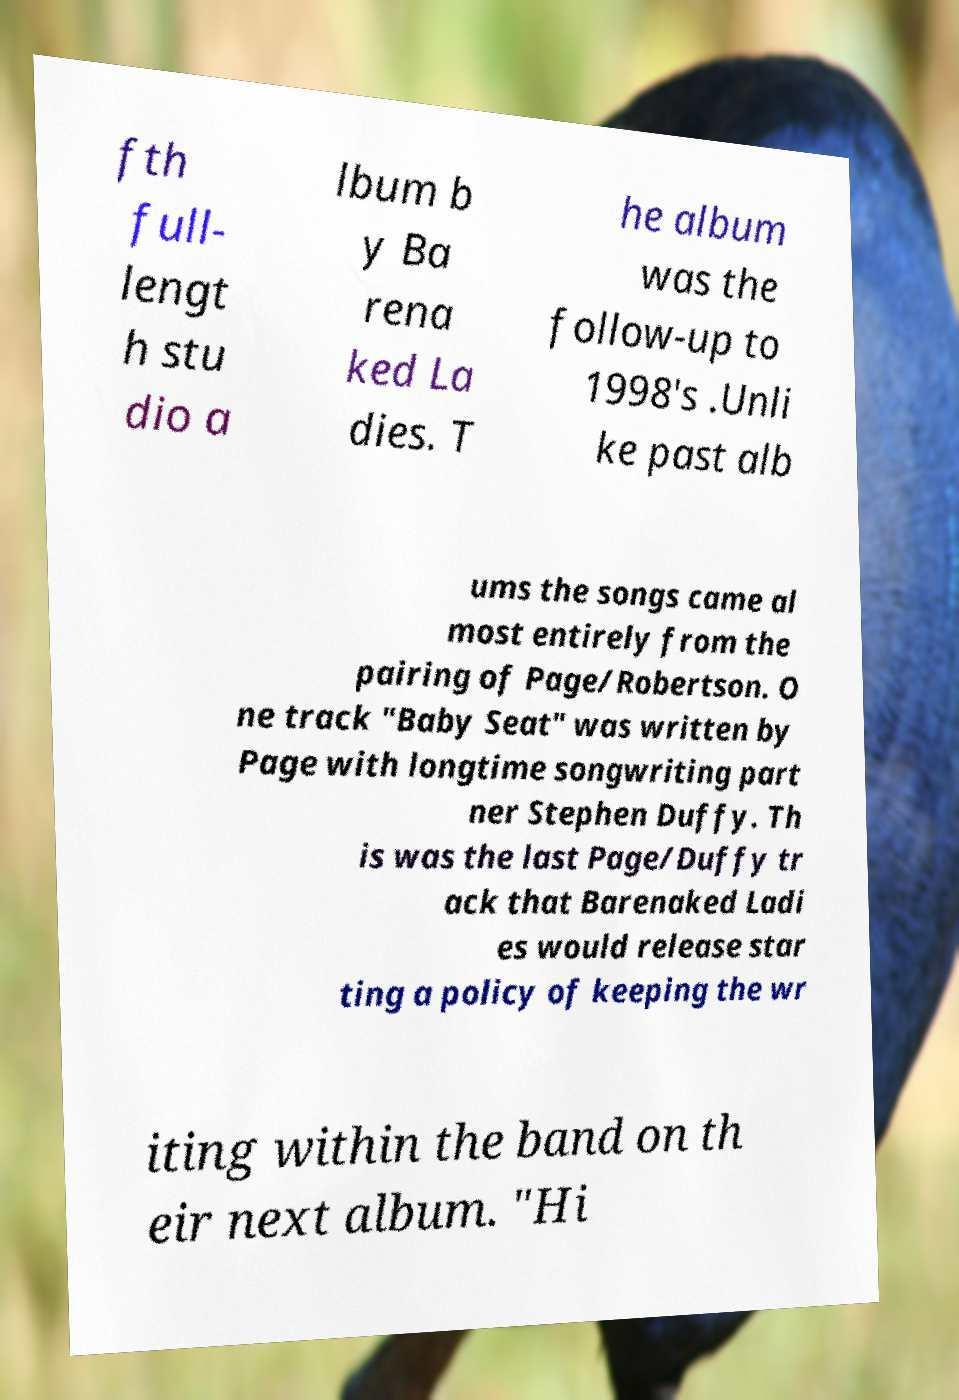I need the written content from this picture converted into text. Can you do that? fth full- lengt h stu dio a lbum b y Ba rena ked La dies. T he album was the follow-up to 1998's .Unli ke past alb ums the songs came al most entirely from the pairing of Page/Robertson. O ne track "Baby Seat" was written by Page with longtime songwriting part ner Stephen Duffy. Th is was the last Page/Duffy tr ack that Barenaked Ladi es would release star ting a policy of keeping the wr iting within the band on th eir next album. "Hi 